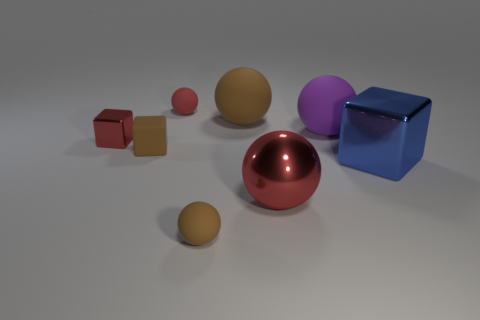Is there a metallic thing that has the same shape as the large purple rubber object?
Your answer should be compact. Yes. What is the shape of the big brown matte object?
Your answer should be compact. Sphere. Are there more large blue shiny blocks that are behind the small red matte object than small red metal things that are to the right of the blue object?
Your response must be concise. No. What material is the red thing that is both in front of the big purple sphere and left of the small brown matte sphere?
Keep it short and to the point. Metal. There is a small red thing that is the same shape as the blue thing; what is its material?
Your response must be concise. Metal. There is a purple matte sphere behind the shiny thing that is to the right of the big red object; what number of big brown matte things are in front of it?
Offer a terse response. 0. Is there any other thing that has the same color as the tiny metallic cube?
Offer a very short reply. Yes. How many red things are to the right of the tiny red metallic thing and in front of the small red matte sphere?
Offer a very short reply. 1. Does the thing in front of the large red metal thing have the same size as the red ball that is in front of the large purple sphere?
Your response must be concise. No. What number of objects are either metallic blocks that are on the left side of the large red shiny thing or red metal spheres?
Offer a very short reply. 2. 